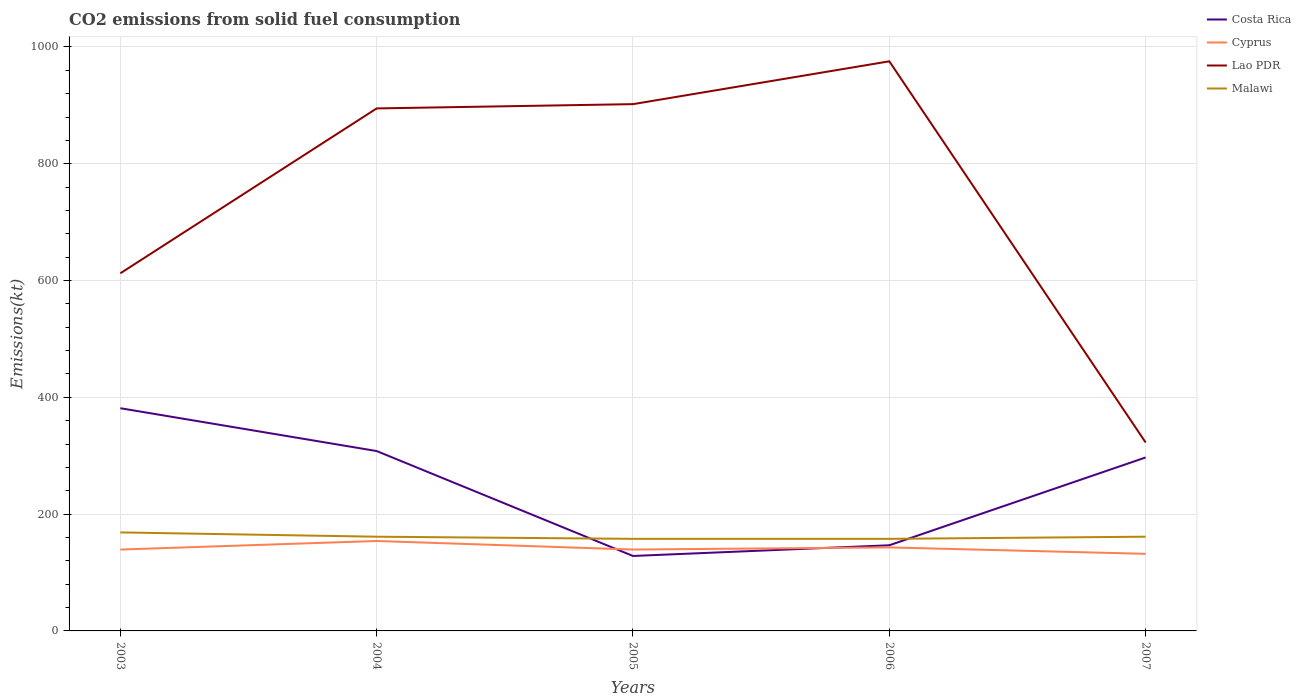How many different coloured lines are there?
Keep it short and to the point. 4. Across all years, what is the maximum amount of CO2 emitted in Cyprus?
Your answer should be very brief. 132.01. In which year was the amount of CO2 emitted in Cyprus maximum?
Offer a very short reply. 2007. What is the total amount of CO2 emitted in Costa Rica in the graph?
Offer a very short reply. -150.35. What is the difference between the highest and the second highest amount of CO2 emitted in Cyprus?
Ensure brevity in your answer.  22. How many lines are there?
Your answer should be compact. 4. How many years are there in the graph?
Offer a terse response. 5. What is the title of the graph?
Your answer should be compact. CO2 emissions from solid fuel consumption. Does "Azerbaijan" appear as one of the legend labels in the graph?
Your response must be concise. No. What is the label or title of the Y-axis?
Make the answer very short. Emissions(kt). What is the Emissions(kt) in Costa Rica in 2003?
Your response must be concise. 381.37. What is the Emissions(kt) in Cyprus in 2003?
Ensure brevity in your answer.  139.35. What is the Emissions(kt) in Lao PDR in 2003?
Your answer should be compact. 612.39. What is the Emissions(kt) in Malawi in 2003?
Offer a terse response. 168.68. What is the Emissions(kt) in Costa Rica in 2004?
Ensure brevity in your answer.  308.03. What is the Emissions(kt) of Cyprus in 2004?
Provide a succinct answer. 154.01. What is the Emissions(kt) of Lao PDR in 2004?
Keep it short and to the point. 894.75. What is the Emissions(kt) of Malawi in 2004?
Make the answer very short. 161.35. What is the Emissions(kt) in Costa Rica in 2005?
Ensure brevity in your answer.  128.34. What is the Emissions(kt) of Cyprus in 2005?
Provide a short and direct response. 139.35. What is the Emissions(kt) in Lao PDR in 2005?
Offer a very short reply. 902.08. What is the Emissions(kt) of Malawi in 2005?
Offer a terse response. 157.68. What is the Emissions(kt) in Costa Rica in 2006?
Ensure brevity in your answer.  146.68. What is the Emissions(kt) in Cyprus in 2006?
Provide a succinct answer. 143.01. What is the Emissions(kt) of Lao PDR in 2006?
Offer a terse response. 975.42. What is the Emissions(kt) of Malawi in 2006?
Keep it short and to the point. 157.68. What is the Emissions(kt) in Costa Rica in 2007?
Your answer should be very brief. 297.03. What is the Emissions(kt) in Cyprus in 2007?
Offer a terse response. 132.01. What is the Emissions(kt) in Lao PDR in 2007?
Offer a terse response. 322.7. What is the Emissions(kt) of Malawi in 2007?
Provide a succinct answer. 161.35. Across all years, what is the maximum Emissions(kt) of Costa Rica?
Provide a short and direct response. 381.37. Across all years, what is the maximum Emissions(kt) of Cyprus?
Give a very brief answer. 154.01. Across all years, what is the maximum Emissions(kt) in Lao PDR?
Provide a succinct answer. 975.42. Across all years, what is the maximum Emissions(kt) in Malawi?
Ensure brevity in your answer.  168.68. Across all years, what is the minimum Emissions(kt) in Costa Rica?
Make the answer very short. 128.34. Across all years, what is the minimum Emissions(kt) of Cyprus?
Your answer should be very brief. 132.01. Across all years, what is the minimum Emissions(kt) in Lao PDR?
Make the answer very short. 322.7. Across all years, what is the minimum Emissions(kt) in Malawi?
Keep it short and to the point. 157.68. What is the total Emissions(kt) of Costa Rica in the graph?
Your answer should be very brief. 1261.45. What is the total Emissions(kt) in Cyprus in the graph?
Ensure brevity in your answer.  707.73. What is the total Emissions(kt) in Lao PDR in the graph?
Make the answer very short. 3707.34. What is the total Emissions(kt) in Malawi in the graph?
Keep it short and to the point. 806.74. What is the difference between the Emissions(kt) of Costa Rica in 2003 and that in 2004?
Make the answer very short. 73.34. What is the difference between the Emissions(kt) of Cyprus in 2003 and that in 2004?
Give a very brief answer. -14.67. What is the difference between the Emissions(kt) of Lao PDR in 2003 and that in 2004?
Provide a succinct answer. -282.36. What is the difference between the Emissions(kt) of Malawi in 2003 and that in 2004?
Offer a very short reply. 7.33. What is the difference between the Emissions(kt) of Costa Rica in 2003 and that in 2005?
Your answer should be very brief. 253.02. What is the difference between the Emissions(kt) in Lao PDR in 2003 and that in 2005?
Your answer should be very brief. -289.69. What is the difference between the Emissions(kt) of Malawi in 2003 and that in 2005?
Offer a terse response. 11. What is the difference between the Emissions(kt) of Costa Rica in 2003 and that in 2006?
Your answer should be very brief. 234.69. What is the difference between the Emissions(kt) in Cyprus in 2003 and that in 2006?
Offer a very short reply. -3.67. What is the difference between the Emissions(kt) in Lao PDR in 2003 and that in 2006?
Offer a terse response. -363.03. What is the difference between the Emissions(kt) in Malawi in 2003 and that in 2006?
Give a very brief answer. 11. What is the difference between the Emissions(kt) of Costa Rica in 2003 and that in 2007?
Offer a terse response. 84.34. What is the difference between the Emissions(kt) in Cyprus in 2003 and that in 2007?
Ensure brevity in your answer.  7.33. What is the difference between the Emissions(kt) of Lao PDR in 2003 and that in 2007?
Give a very brief answer. 289.69. What is the difference between the Emissions(kt) in Malawi in 2003 and that in 2007?
Provide a succinct answer. 7.33. What is the difference between the Emissions(kt) of Costa Rica in 2004 and that in 2005?
Ensure brevity in your answer.  179.68. What is the difference between the Emissions(kt) in Cyprus in 2004 and that in 2005?
Offer a very short reply. 14.67. What is the difference between the Emissions(kt) of Lao PDR in 2004 and that in 2005?
Keep it short and to the point. -7.33. What is the difference between the Emissions(kt) of Malawi in 2004 and that in 2005?
Make the answer very short. 3.67. What is the difference between the Emissions(kt) in Costa Rica in 2004 and that in 2006?
Your answer should be very brief. 161.35. What is the difference between the Emissions(kt) in Cyprus in 2004 and that in 2006?
Make the answer very short. 11. What is the difference between the Emissions(kt) of Lao PDR in 2004 and that in 2006?
Provide a succinct answer. -80.67. What is the difference between the Emissions(kt) in Malawi in 2004 and that in 2006?
Make the answer very short. 3.67. What is the difference between the Emissions(kt) in Costa Rica in 2004 and that in 2007?
Keep it short and to the point. 11. What is the difference between the Emissions(kt) of Cyprus in 2004 and that in 2007?
Ensure brevity in your answer.  22. What is the difference between the Emissions(kt) of Lao PDR in 2004 and that in 2007?
Provide a succinct answer. 572.05. What is the difference between the Emissions(kt) in Costa Rica in 2005 and that in 2006?
Keep it short and to the point. -18.34. What is the difference between the Emissions(kt) of Cyprus in 2005 and that in 2006?
Give a very brief answer. -3.67. What is the difference between the Emissions(kt) of Lao PDR in 2005 and that in 2006?
Your answer should be compact. -73.34. What is the difference between the Emissions(kt) of Costa Rica in 2005 and that in 2007?
Ensure brevity in your answer.  -168.68. What is the difference between the Emissions(kt) of Cyprus in 2005 and that in 2007?
Make the answer very short. 7.33. What is the difference between the Emissions(kt) of Lao PDR in 2005 and that in 2007?
Your answer should be compact. 579.39. What is the difference between the Emissions(kt) of Malawi in 2005 and that in 2007?
Offer a very short reply. -3.67. What is the difference between the Emissions(kt) in Costa Rica in 2006 and that in 2007?
Give a very brief answer. -150.35. What is the difference between the Emissions(kt) in Cyprus in 2006 and that in 2007?
Make the answer very short. 11. What is the difference between the Emissions(kt) in Lao PDR in 2006 and that in 2007?
Offer a very short reply. 652.73. What is the difference between the Emissions(kt) of Malawi in 2006 and that in 2007?
Your response must be concise. -3.67. What is the difference between the Emissions(kt) in Costa Rica in 2003 and the Emissions(kt) in Cyprus in 2004?
Keep it short and to the point. 227.35. What is the difference between the Emissions(kt) of Costa Rica in 2003 and the Emissions(kt) of Lao PDR in 2004?
Provide a short and direct response. -513.38. What is the difference between the Emissions(kt) in Costa Rica in 2003 and the Emissions(kt) in Malawi in 2004?
Keep it short and to the point. 220.02. What is the difference between the Emissions(kt) of Cyprus in 2003 and the Emissions(kt) of Lao PDR in 2004?
Ensure brevity in your answer.  -755.4. What is the difference between the Emissions(kt) in Cyprus in 2003 and the Emissions(kt) in Malawi in 2004?
Offer a very short reply. -22. What is the difference between the Emissions(kt) of Lao PDR in 2003 and the Emissions(kt) of Malawi in 2004?
Your answer should be compact. 451.04. What is the difference between the Emissions(kt) in Costa Rica in 2003 and the Emissions(kt) in Cyprus in 2005?
Make the answer very short. 242.02. What is the difference between the Emissions(kt) of Costa Rica in 2003 and the Emissions(kt) of Lao PDR in 2005?
Your answer should be very brief. -520.71. What is the difference between the Emissions(kt) in Costa Rica in 2003 and the Emissions(kt) in Malawi in 2005?
Provide a short and direct response. 223.69. What is the difference between the Emissions(kt) of Cyprus in 2003 and the Emissions(kt) of Lao PDR in 2005?
Ensure brevity in your answer.  -762.74. What is the difference between the Emissions(kt) of Cyprus in 2003 and the Emissions(kt) of Malawi in 2005?
Your answer should be very brief. -18.34. What is the difference between the Emissions(kt) of Lao PDR in 2003 and the Emissions(kt) of Malawi in 2005?
Your answer should be compact. 454.71. What is the difference between the Emissions(kt) in Costa Rica in 2003 and the Emissions(kt) in Cyprus in 2006?
Provide a short and direct response. 238.35. What is the difference between the Emissions(kt) of Costa Rica in 2003 and the Emissions(kt) of Lao PDR in 2006?
Ensure brevity in your answer.  -594.05. What is the difference between the Emissions(kt) of Costa Rica in 2003 and the Emissions(kt) of Malawi in 2006?
Make the answer very short. 223.69. What is the difference between the Emissions(kt) in Cyprus in 2003 and the Emissions(kt) in Lao PDR in 2006?
Offer a terse response. -836.08. What is the difference between the Emissions(kt) of Cyprus in 2003 and the Emissions(kt) of Malawi in 2006?
Offer a terse response. -18.34. What is the difference between the Emissions(kt) of Lao PDR in 2003 and the Emissions(kt) of Malawi in 2006?
Give a very brief answer. 454.71. What is the difference between the Emissions(kt) in Costa Rica in 2003 and the Emissions(kt) in Cyprus in 2007?
Offer a very short reply. 249.36. What is the difference between the Emissions(kt) in Costa Rica in 2003 and the Emissions(kt) in Lao PDR in 2007?
Provide a succinct answer. 58.67. What is the difference between the Emissions(kt) of Costa Rica in 2003 and the Emissions(kt) of Malawi in 2007?
Keep it short and to the point. 220.02. What is the difference between the Emissions(kt) of Cyprus in 2003 and the Emissions(kt) of Lao PDR in 2007?
Keep it short and to the point. -183.35. What is the difference between the Emissions(kt) in Cyprus in 2003 and the Emissions(kt) in Malawi in 2007?
Your answer should be compact. -22. What is the difference between the Emissions(kt) in Lao PDR in 2003 and the Emissions(kt) in Malawi in 2007?
Your answer should be very brief. 451.04. What is the difference between the Emissions(kt) of Costa Rica in 2004 and the Emissions(kt) of Cyprus in 2005?
Your answer should be compact. 168.68. What is the difference between the Emissions(kt) in Costa Rica in 2004 and the Emissions(kt) in Lao PDR in 2005?
Make the answer very short. -594.05. What is the difference between the Emissions(kt) in Costa Rica in 2004 and the Emissions(kt) in Malawi in 2005?
Ensure brevity in your answer.  150.35. What is the difference between the Emissions(kt) of Cyprus in 2004 and the Emissions(kt) of Lao PDR in 2005?
Your answer should be compact. -748.07. What is the difference between the Emissions(kt) of Cyprus in 2004 and the Emissions(kt) of Malawi in 2005?
Your response must be concise. -3.67. What is the difference between the Emissions(kt) in Lao PDR in 2004 and the Emissions(kt) in Malawi in 2005?
Provide a short and direct response. 737.07. What is the difference between the Emissions(kt) in Costa Rica in 2004 and the Emissions(kt) in Cyprus in 2006?
Offer a very short reply. 165.01. What is the difference between the Emissions(kt) of Costa Rica in 2004 and the Emissions(kt) of Lao PDR in 2006?
Ensure brevity in your answer.  -667.39. What is the difference between the Emissions(kt) in Costa Rica in 2004 and the Emissions(kt) in Malawi in 2006?
Your answer should be compact. 150.35. What is the difference between the Emissions(kt) in Cyprus in 2004 and the Emissions(kt) in Lao PDR in 2006?
Provide a short and direct response. -821.41. What is the difference between the Emissions(kt) in Cyprus in 2004 and the Emissions(kt) in Malawi in 2006?
Make the answer very short. -3.67. What is the difference between the Emissions(kt) of Lao PDR in 2004 and the Emissions(kt) of Malawi in 2006?
Give a very brief answer. 737.07. What is the difference between the Emissions(kt) of Costa Rica in 2004 and the Emissions(kt) of Cyprus in 2007?
Your response must be concise. 176.02. What is the difference between the Emissions(kt) in Costa Rica in 2004 and the Emissions(kt) in Lao PDR in 2007?
Provide a short and direct response. -14.67. What is the difference between the Emissions(kt) in Costa Rica in 2004 and the Emissions(kt) in Malawi in 2007?
Provide a succinct answer. 146.68. What is the difference between the Emissions(kt) in Cyprus in 2004 and the Emissions(kt) in Lao PDR in 2007?
Ensure brevity in your answer.  -168.68. What is the difference between the Emissions(kt) of Cyprus in 2004 and the Emissions(kt) of Malawi in 2007?
Make the answer very short. -7.33. What is the difference between the Emissions(kt) in Lao PDR in 2004 and the Emissions(kt) in Malawi in 2007?
Your response must be concise. 733.4. What is the difference between the Emissions(kt) of Costa Rica in 2005 and the Emissions(kt) of Cyprus in 2006?
Your answer should be compact. -14.67. What is the difference between the Emissions(kt) in Costa Rica in 2005 and the Emissions(kt) in Lao PDR in 2006?
Give a very brief answer. -847.08. What is the difference between the Emissions(kt) of Costa Rica in 2005 and the Emissions(kt) of Malawi in 2006?
Your answer should be compact. -29.34. What is the difference between the Emissions(kt) in Cyprus in 2005 and the Emissions(kt) in Lao PDR in 2006?
Offer a very short reply. -836.08. What is the difference between the Emissions(kt) of Cyprus in 2005 and the Emissions(kt) of Malawi in 2006?
Your answer should be very brief. -18.34. What is the difference between the Emissions(kt) of Lao PDR in 2005 and the Emissions(kt) of Malawi in 2006?
Your response must be concise. 744.4. What is the difference between the Emissions(kt) of Costa Rica in 2005 and the Emissions(kt) of Cyprus in 2007?
Ensure brevity in your answer.  -3.67. What is the difference between the Emissions(kt) in Costa Rica in 2005 and the Emissions(kt) in Lao PDR in 2007?
Provide a short and direct response. -194.35. What is the difference between the Emissions(kt) in Costa Rica in 2005 and the Emissions(kt) in Malawi in 2007?
Offer a very short reply. -33. What is the difference between the Emissions(kt) of Cyprus in 2005 and the Emissions(kt) of Lao PDR in 2007?
Ensure brevity in your answer.  -183.35. What is the difference between the Emissions(kt) of Cyprus in 2005 and the Emissions(kt) of Malawi in 2007?
Your response must be concise. -22. What is the difference between the Emissions(kt) in Lao PDR in 2005 and the Emissions(kt) in Malawi in 2007?
Make the answer very short. 740.73. What is the difference between the Emissions(kt) of Costa Rica in 2006 and the Emissions(kt) of Cyprus in 2007?
Offer a terse response. 14.67. What is the difference between the Emissions(kt) of Costa Rica in 2006 and the Emissions(kt) of Lao PDR in 2007?
Your response must be concise. -176.02. What is the difference between the Emissions(kt) of Costa Rica in 2006 and the Emissions(kt) of Malawi in 2007?
Keep it short and to the point. -14.67. What is the difference between the Emissions(kt) of Cyprus in 2006 and the Emissions(kt) of Lao PDR in 2007?
Offer a terse response. -179.68. What is the difference between the Emissions(kt) in Cyprus in 2006 and the Emissions(kt) in Malawi in 2007?
Offer a terse response. -18.34. What is the difference between the Emissions(kt) in Lao PDR in 2006 and the Emissions(kt) in Malawi in 2007?
Your answer should be compact. 814.07. What is the average Emissions(kt) in Costa Rica per year?
Offer a terse response. 252.29. What is the average Emissions(kt) of Cyprus per year?
Your answer should be compact. 141.55. What is the average Emissions(kt) of Lao PDR per year?
Your response must be concise. 741.47. What is the average Emissions(kt) of Malawi per year?
Make the answer very short. 161.35. In the year 2003, what is the difference between the Emissions(kt) of Costa Rica and Emissions(kt) of Cyprus?
Offer a terse response. 242.02. In the year 2003, what is the difference between the Emissions(kt) in Costa Rica and Emissions(kt) in Lao PDR?
Ensure brevity in your answer.  -231.02. In the year 2003, what is the difference between the Emissions(kt) of Costa Rica and Emissions(kt) of Malawi?
Your response must be concise. 212.69. In the year 2003, what is the difference between the Emissions(kt) in Cyprus and Emissions(kt) in Lao PDR?
Your answer should be very brief. -473.04. In the year 2003, what is the difference between the Emissions(kt) in Cyprus and Emissions(kt) in Malawi?
Your response must be concise. -29.34. In the year 2003, what is the difference between the Emissions(kt) in Lao PDR and Emissions(kt) in Malawi?
Your response must be concise. 443.71. In the year 2004, what is the difference between the Emissions(kt) in Costa Rica and Emissions(kt) in Cyprus?
Offer a terse response. 154.01. In the year 2004, what is the difference between the Emissions(kt) of Costa Rica and Emissions(kt) of Lao PDR?
Offer a very short reply. -586.72. In the year 2004, what is the difference between the Emissions(kt) in Costa Rica and Emissions(kt) in Malawi?
Your response must be concise. 146.68. In the year 2004, what is the difference between the Emissions(kt) of Cyprus and Emissions(kt) of Lao PDR?
Your response must be concise. -740.73. In the year 2004, what is the difference between the Emissions(kt) of Cyprus and Emissions(kt) of Malawi?
Your answer should be compact. -7.33. In the year 2004, what is the difference between the Emissions(kt) of Lao PDR and Emissions(kt) of Malawi?
Ensure brevity in your answer.  733.4. In the year 2005, what is the difference between the Emissions(kt) in Costa Rica and Emissions(kt) in Cyprus?
Provide a short and direct response. -11. In the year 2005, what is the difference between the Emissions(kt) in Costa Rica and Emissions(kt) in Lao PDR?
Offer a very short reply. -773.74. In the year 2005, what is the difference between the Emissions(kt) in Costa Rica and Emissions(kt) in Malawi?
Keep it short and to the point. -29.34. In the year 2005, what is the difference between the Emissions(kt) in Cyprus and Emissions(kt) in Lao PDR?
Offer a terse response. -762.74. In the year 2005, what is the difference between the Emissions(kt) in Cyprus and Emissions(kt) in Malawi?
Give a very brief answer. -18.34. In the year 2005, what is the difference between the Emissions(kt) of Lao PDR and Emissions(kt) of Malawi?
Your answer should be compact. 744.4. In the year 2006, what is the difference between the Emissions(kt) of Costa Rica and Emissions(kt) of Cyprus?
Your answer should be very brief. 3.67. In the year 2006, what is the difference between the Emissions(kt) in Costa Rica and Emissions(kt) in Lao PDR?
Your response must be concise. -828.74. In the year 2006, what is the difference between the Emissions(kt) in Costa Rica and Emissions(kt) in Malawi?
Your answer should be very brief. -11. In the year 2006, what is the difference between the Emissions(kt) in Cyprus and Emissions(kt) in Lao PDR?
Offer a very short reply. -832.41. In the year 2006, what is the difference between the Emissions(kt) of Cyprus and Emissions(kt) of Malawi?
Make the answer very short. -14.67. In the year 2006, what is the difference between the Emissions(kt) in Lao PDR and Emissions(kt) in Malawi?
Offer a terse response. 817.74. In the year 2007, what is the difference between the Emissions(kt) of Costa Rica and Emissions(kt) of Cyprus?
Ensure brevity in your answer.  165.01. In the year 2007, what is the difference between the Emissions(kt) of Costa Rica and Emissions(kt) of Lao PDR?
Provide a succinct answer. -25.67. In the year 2007, what is the difference between the Emissions(kt) of Costa Rica and Emissions(kt) of Malawi?
Your answer should be compact. 135.68. In the year 2007, what is the difference between the Emissions(kt) in Cyprus and Emissions(kt) in Lao PDR?
Give a very brief answer. -190.68. In the year 2007, what is the difference between the Emissions(kt) of Cyprus and Emissions(kt) of Malawi?
Ensure brevity in your answer.  -29.34. In the year 2007, what is the difference between the Emissions(kt) of Lao PDR and Emissions(kt) of Malawi?
Your answer should be compact. 161.35. What is the ratio of the Emissions(kt) in Costa Rica in 2003 to that in 2004?
Your answer should be very brief. 1.24. What is the ratio of the Emissions(kt) of Cyprus in 2003 to that in 2004?
Make the answer very short. 0.9. What is the ratio of the Emissions(kt) in Lao PDR in 2003 to that in 2004?
Provide a succinct answer. 0.68. What is the ratio of the Emissions(kt) in Malawi in 2003 to that in 2004?
Your response must be concise. 1.05. What is the ratio of the Emissions(kt) of Costa Rica in 2003 to that in 2005?
Keep it short and to the point. 2.97. What is the ratio of the Emissions(kt) of Lao PDR in 2003 to that in 2005?
Ensure brevity in your answer.  0.68. What is the ratio of the Emissions(kt) in Malawi in 2003 to that in 2005?
Keep it short and to the point. 1.07. What is the ratio of the Emissions(kt) in Cyprus in 2003 to that in 2006?
Make the answer very short. 0.97. What is the ratio of the Emissions(kt) in Lao PDR in 2003 to that in 2006?
Offer a very short reply. 0.63. What is the ratio of the Emissions(kt) of Malawi in 2003 to that in 2006?
Give a very brief answer. 1.07. What is the ratio of the Emissions(kt) of Costa Rica in 2003 to that in 2007?
Make the answer very short. 1.28. What is the ratio of the Emissions(kt) in Cyprus in 2003 to that in 2007?
Keep it short and to the point. 1.06. What is the ratio of the Emissions(kt) in Lao PDR in 2003 to that in 2007?
Offer a very short reply. 1.9. What is the ratio of the Emissions(kt) in Malawi in 2003 to that in 2007?
Offer a terse response. 1.05. What is the ratio of the Emissions(kt) of Cyprus in 2004 to that in 2005?
Your answer should be compact. 1.11. What is the ratio of the Emissions(kt) in Malawi in 2004 to that in 2005?
Ensure brevity in your answer.  1.02. What is the ratio of the Emissions(kt) in Costa Rica in 2004 to that in 2006?
Offer a terse response. 2.1. What is the ratio of the Emissions(kt) in Cyprus in 2004 to that in 2006?
Provide a succinct answer. 1.08. What is the ratio of the Emissions(kt) in Lao PDR in 2004 to that in 2006?
Offer a very short reply. 0.92. What is the ratio of the Emissions(kt) in Malawi in 2004 to that in 2006?
Provide a succinct answer. 1.02. What is the ratio of the Emissions(kt) of Lao PDR in 2004 to that in 2007?
Your answer should be very brief. 2.77. What is the ratio of the Emissions(kt) in Malawi in 2004 to that in 2007?
Offer a terse response. 1. What is the ratio of the Emissions(kt) in Costa Rica in 2005 to that in 2006?
Provide a short and direct response. 0.88. What is the ratio of the Emissions(kt) in Cyprus in 2005 to that in 2006?
Your answer should be very brief. 0.97. What is the ratio of the Emissions(kt) in Lao PDR in 2005 to that in 2006?
Keep it short and to the point. 0.92. What is the ratio of the Emissions(kt) in Malawi in 2005 to that in 2006?
Provide a short and direct response. 1. What is the ratio of the Emissions(kt) in Costa Rica in 2005 to that in 2007?
Offer a very short reply. 0.43. What is the ratio of the Emissions(kt) in Cyprus in 2005 to that in 2007?
Your response must be concise. 1.06. What is the ratio of the Emissions(kt) in Lao PDR in 2005 to that in 2007?
Your response must be concise. 2.8. What is the ratio of the Emissions(kt) in Malawi in 2005 to that in 2007?
Ensure brevity in your answer.  0.98. What is the ratio of the Emissions(kt) of Costa Rica in 2006 to that in 2007?
Provide a short and direct response. 0.49. What is the ratio of the Emissions(kt) in Lao PDR in 2006 to that in 2007?
Provide a succinct answer. 3.02. What is the ratio of the Emissions(kt) in Malawi in 2006 to that in 2007?
Your response must be concise. 0.98. What is the difference between the highest and the second highest Emissions(kt) of Costa Rica?
Provide a succinct answer. 73.34. What is the difference between the highest and the second highest Emissions(kt) in Cyprus?
Make the answer very short. 11. What is the difference between the highest and the second highest Emissions(kt) of Lao PDR?
Your response must be concise. 73.34. What is the difference between the highest and the second highest Emissions(kt) of Malawi?
Your answer should be very brief. 7.33. What is the difference between the highest and the lowest Emissions(kt) of Costa Rica?
Your response must be concise. 253.02. What is the difference between the highest and the lowest Emissions(kt) of Cyprus?
Provide a short and direct response. 22. What is the difference between the highest and the lowest Emissions(kt) in Lao PDR?
Make the answer very short. 652.73. What is the difference between the highest and the lowest Emissions(kt) in Malawi?
Your response must be concise. 11. 